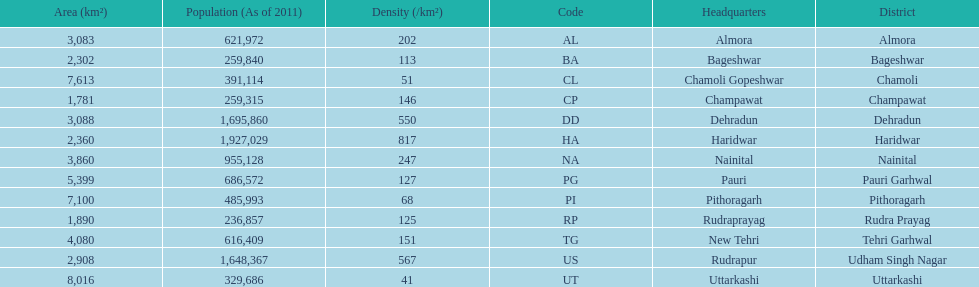Which headquarter has the same district name but has a density of 202? Almora. 